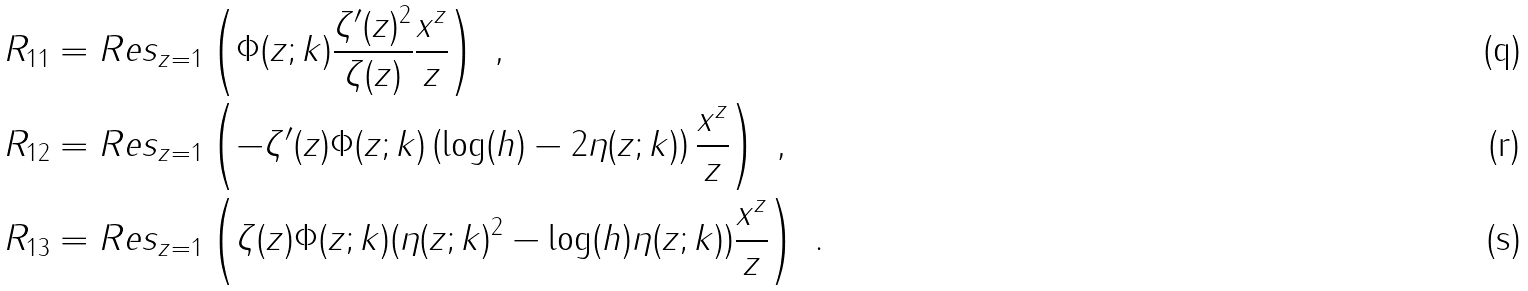Convert formula to latex. <formula><loc_0><loc_0><loc_500><loc_500>R _ { 1 1 } & = R e s _ { z = 1 } \left ( \Phi ( z ; k ) \frac { \zeta ^ { \prime } ( z ) ^ { 2 } } { \zeta ( z ) } \frac { x ^ { z } } { z } \right ) \ , \\ R _ { 1 2 } & = R e s _ { z = 1 } \left ( - \zeta ^ { \prime } ( z ) \Phi ( z ; k ) \left ( \log ( h ) - 2 \eta ( z ; k ) \right ) \frac { x ^ { z } } { z } \right ) \ , \\ R _ { 1 3 } & = R e s _ { z = 1 } \left ( \zeta ( z ) \Phi ( z ; k ) ( \eta ( z ; k ) ^ { 2 } - \log ( h ) \eta ( z ; k ) ) \frac { x ^ { z } } { z } \right ) \ .</formula> 